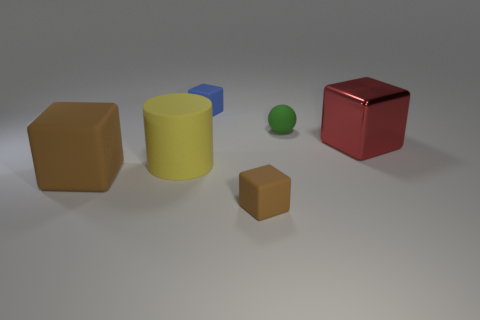Is the cylinder made of the same material as the big cube that is right of the large yellow cylinder?
Your response must be concise. No. Are there any other large matte balls of the same color as the ball?
Offer a terse response. No. What number of other objects are there of the same material as the big brown cube?
Keep it short and to the point. 4. Is the color of the cylinder the same as the matte cube behind the matte sphere?
Provide a succinct answer. No. Are there more brown things that are on the left side of the big rubber block than spheres?
Provide a succinct answer. No. What number of small balls are in front of the small green thing on the right side of the small block on the left side of the small brown matte thing?
Ensure brevity in your answer.  0. There is a small rubber object in front of the red thing; is its shape the same as the big yellow object?
Provide a short and direct response. No. What is the material of the block behind the big red thing?
Your answer should be compact. Rubber. What is the shape of the small rubber object that is both behind the large yellow cylinder and in front of the blue block?
Offer a terse response. Sphere. What is the tiny brown cube made of?
Offer a terse response. Rubber. 